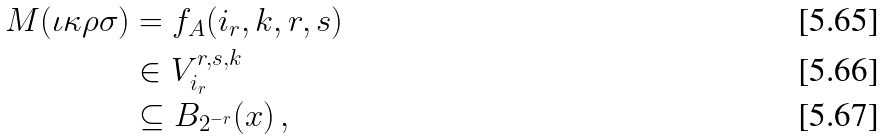<formula> <loc_0><loc_0><loc_500><loc_500>M ( \iota \kappa \rho \sigma ) & = f _ { A } ( i _ { r } , k , r , s ) \\ & \in V _ { i _ { r } } ^ { r , s , k } \\ & \subseteq B _ { 2 ^ { - r } } ( x ) \, ,</formula> 